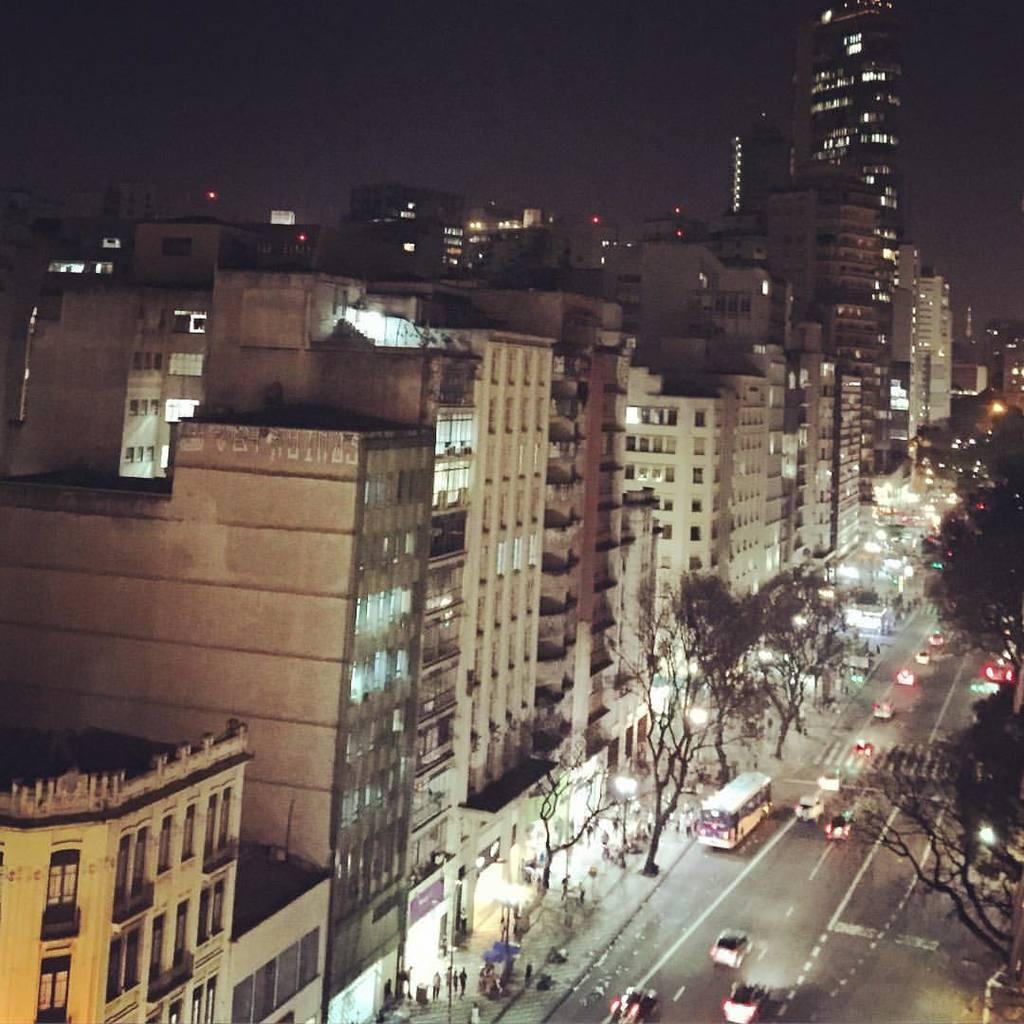What type of structures are present in the image? There are buildings in the image. What is located in front of the buildings? There is a road in front of the buildings. What can be seen on the road? Vehicles are visible on the road. What type of vegetation is present in the image? Trees are visible in the image. What is visible at the top of the image? The sky is visible at the top of the image. What substance are the women using to attack the buildings in the image? There are no women or attacks present in the image; it features buildings, a road, vehicles, trees, and the sky. 